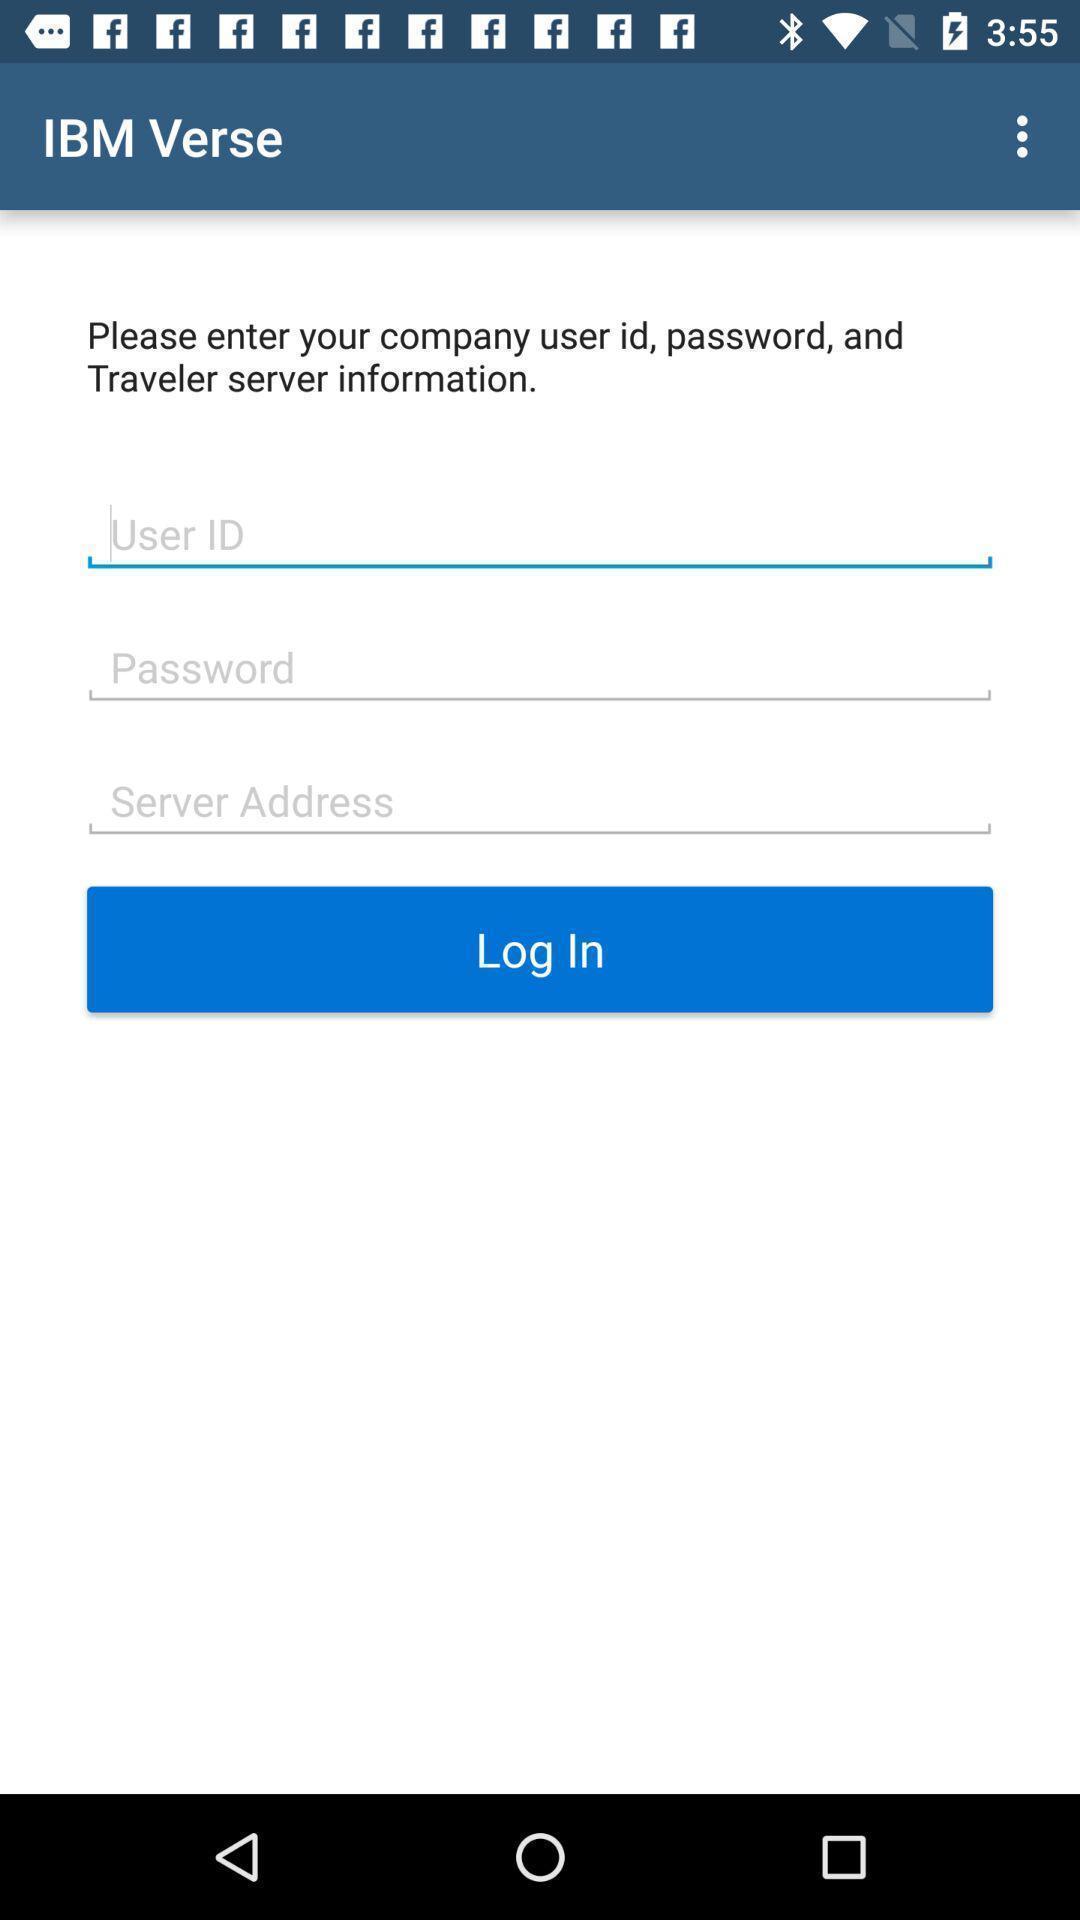Summarize the main components in this picture. Page displaying to enter details. 